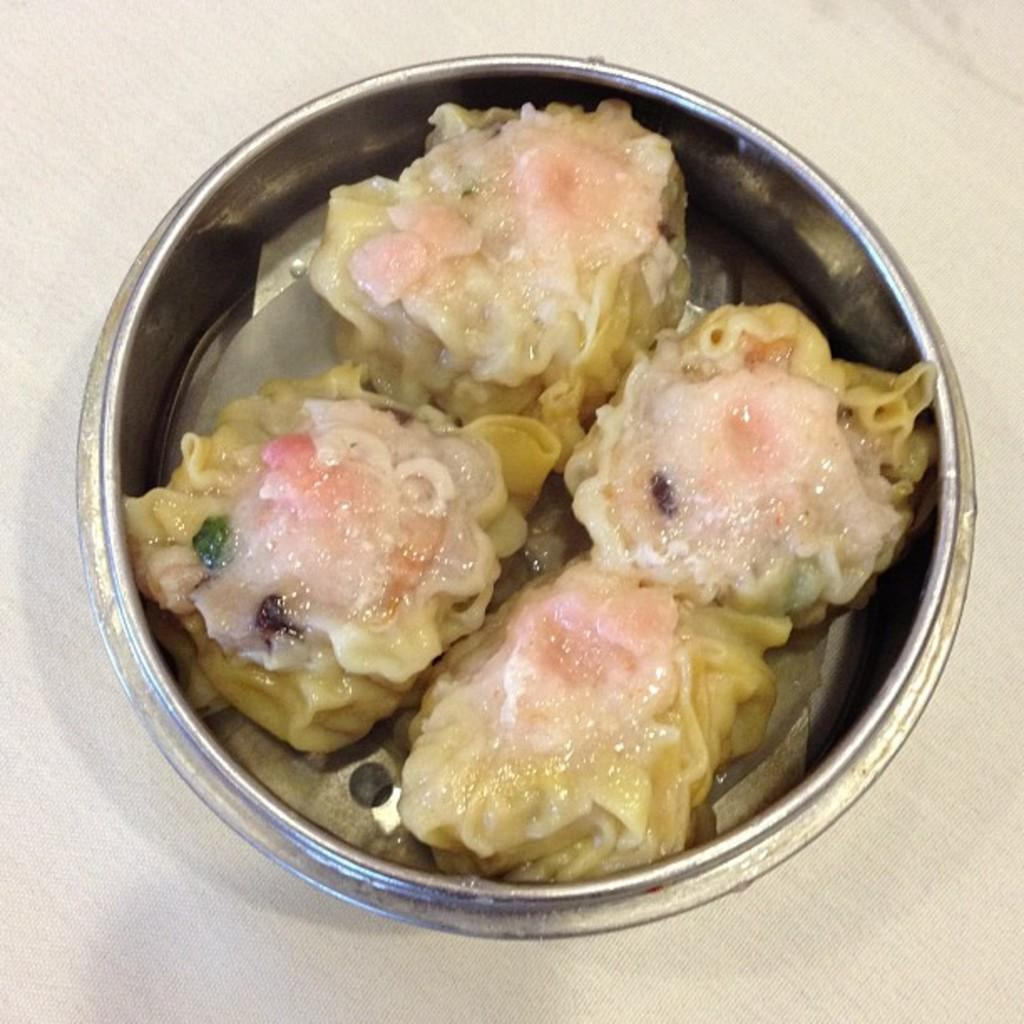What is in the bowl that is visible in the image? There is food in the bowl in the image. What can be seen beneath the bowl? The surface beneath the bowl is white. How many cats are holding onto the bowl in the image? There are no cats present in the image. What is the fifth item in the image? The image only contains a bowl with food and a white surface beneath it, so there is no fifth item to describe. 